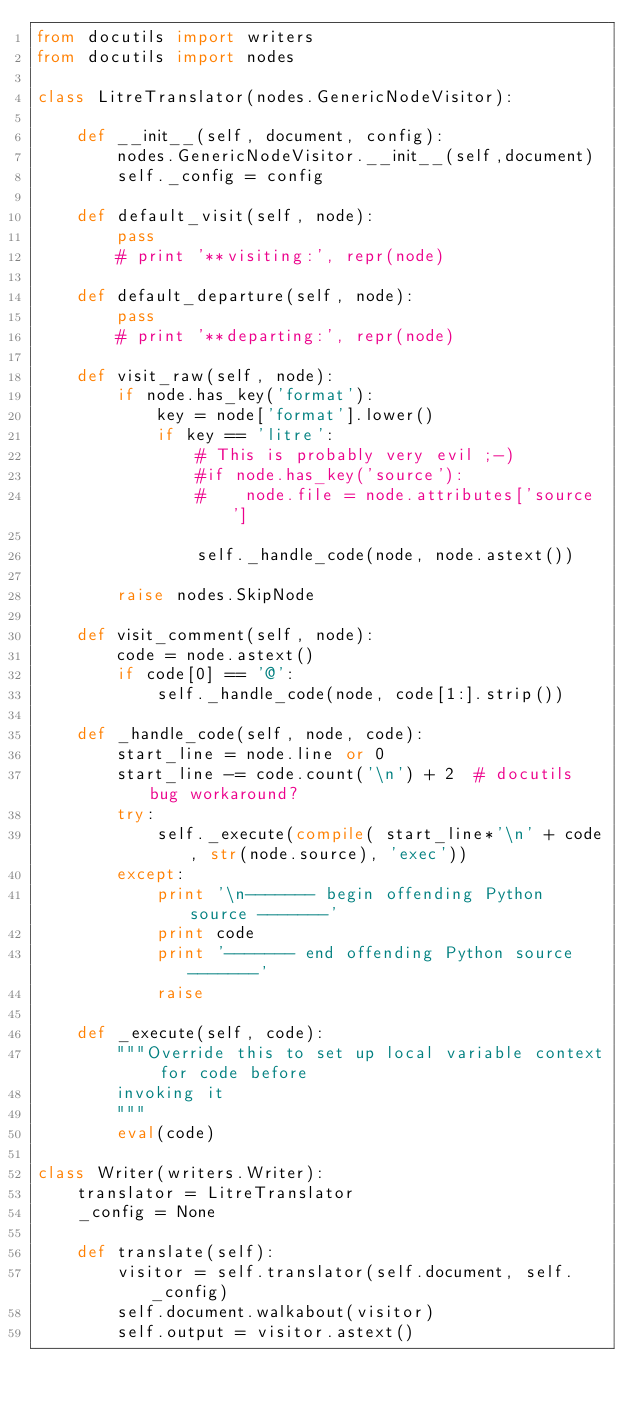Convert code to text. <code><loc_0><loc_0><loc_500><loc_500><_Python_>from docutils import writers
from docutils import nodes

class LitreTranslator(nodes.GenericNodeVisitor):

    def __init__(self, document, config):
        nodes.GenericNodeVisitor.__init__(self,document)
        self._config = config
        
    def default_visit(self, node):
        pass
        # print '**visiting:', repr(node)

    def default_departure(self, node):
        pass
        # print '**departing:', repr(node)

    def visit_raw(self, node):
        if node.has_key('format'):
            key = node['format'].lower()
            if key == 'litre':
                # This is probably very evil ;-)
                #if node.has_key('source'):
                #    node.file = node.attributes['source']
                    
                self._handle_code(node, node.astext())
                
        raise nodes.SkipNode

    def visit_comment(self, node):
        code = node.astext()
        if code[0] == '@':
            self._handle_code(node, code[1:].strip())
                              
    def _handle_code(self, node, code):
        start_line = node.line or 0
        start_line -= code.count('\n') + 2  # docutils bug workaround?
        try:
            self._execute(compile( start_line*'\n' + code, str(node.source), 'exec'))
        except:
            print '\n------- begin offending Python source -------'
            print code            
            print '------- end offending Python source -------'
            raise
            
    def _execute(self, code):
        """Override this to set up local variable context for code before
        invoking it
        """
        eval(code)
        
class Writer(writers.Writer):
    translator = LitreTranslator
    _config = None
    
    def translate(self):
        visitor = self.translator(self.document, self._config)
        self.document.walkabout(visitor)
        self.output = visitor.astext()

    
</code> 